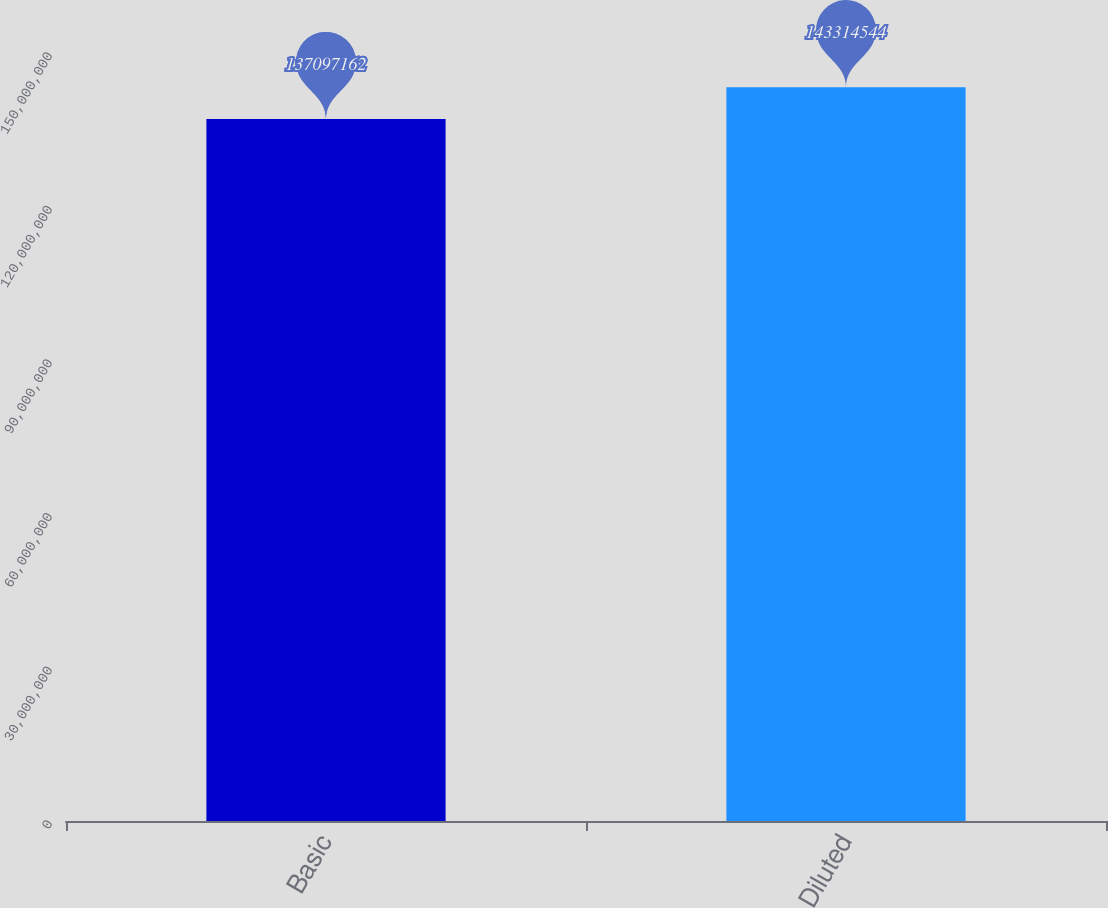Convert chart. <chart><loc_0><loc_0><loc_500><loc_500><bar_chart><fcel>Basic<fcel>Diluted<nl><fcel>1.37097e+08<fcel>1.43315e+08<nl></chart> 